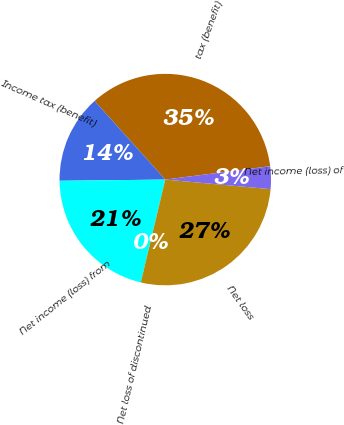Convert chart to OTSL. <chart><loc_0><loc_0><loc_500><loc_500><pie_chart><fcel>tax (benefit)<fcel>Income tax (benefit)<fcel>Net income (loss) from<fcel>Net loss of discontinued<fcel>Net loss<fcel>Net income (loss) of<nl><fcel>34.63%<fcel>13.53%<fcel>21.1%<fcel>0.0%<fcel>27.28%<fcel>3.46%<nl></chart> 